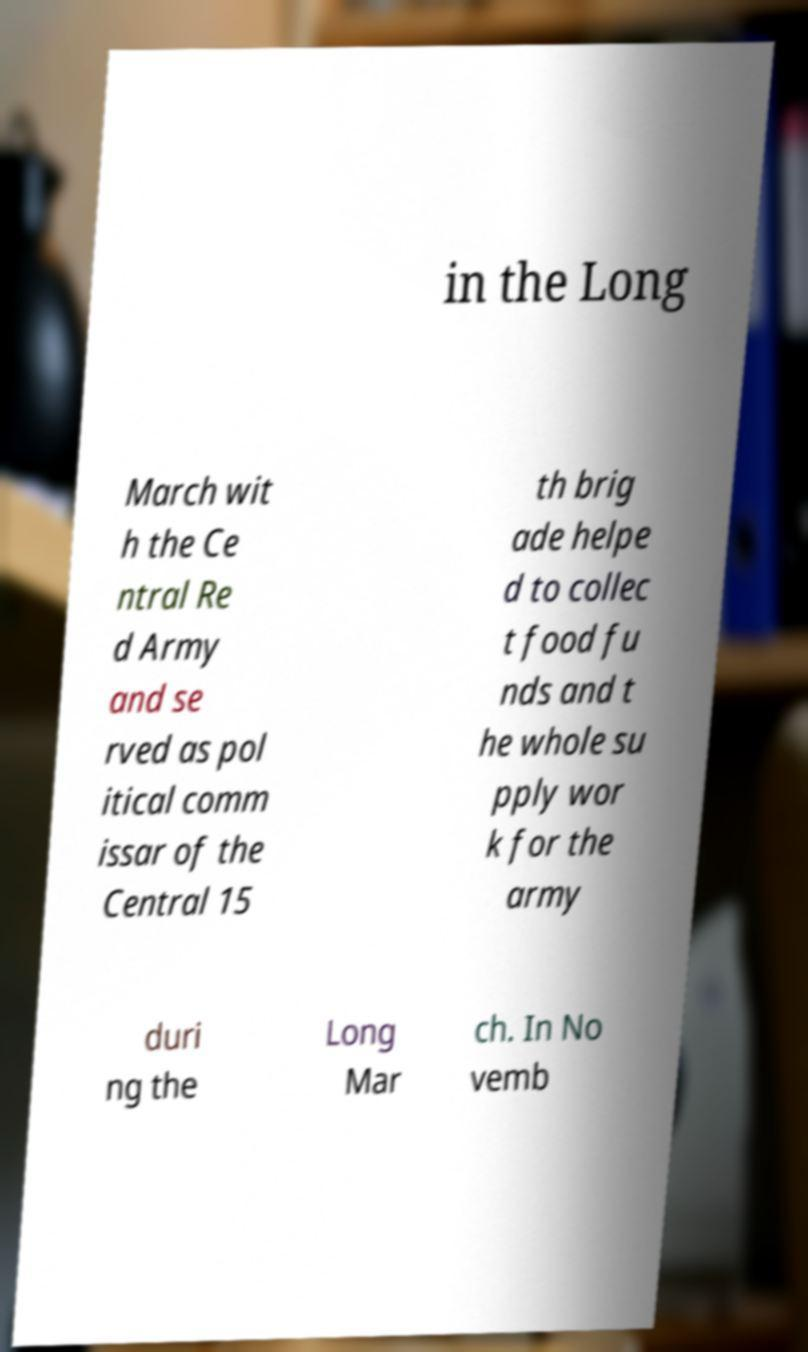For documentation purposes, I need the text within this image transcribed. Could you provide that? in the Long March wit h the Ce ntral Re d Army and se rved as pol itical comm issar of the Central 15 th brig ade helpe d to collec t food fu nds and t he whole su pply wor k for the army duri ng the Long Mar ch. In No vemb 